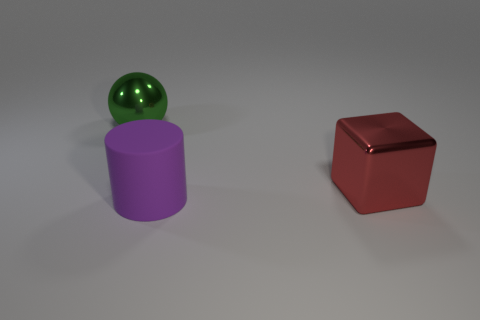There is another object that is the same material as the big red thing; what color is it?
Your response must be concise. Green. Are there more objects behind the large green shiny thing than big purple rubber cylinders that are to the right of the big red metallic object?
Provide a short and direct response. No. Is there a gray matte thing?
Offer a terse response. No. What number of things are large red shiny cubes or tiny green matte spheres?
Provide a succinct answer. 1. Are there any cylinders of the same color as the big block?
Provide a succinct answer. No. How many green spheres are in front of the thing right of the purple rubber object?
Offer a terse response. 0. Is the number of cylinders greater than the number of big blue blocks?
Your answer should be very brief. Yes. Does the green object have the same material as the big cube?
Your response must be concise. Yes. Is the number of big cylinders in front of the red metallic cube the same as the number of tiny green rubber balls?
Your answer should be very brief. No. What number of big green spheres have the same material as the block?
Your answer should be compact. 1. 